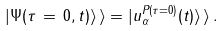<formula> <loc_0><loc_0><loc_500><loc_500>| \Psi ( \tau \, = \, 0 , t ) \rangle \, \rangle = | u _ { \alpha } ^ { P ( \tau = 0 ) } ( t ) \rangle \, \rangle \, .</formula> 